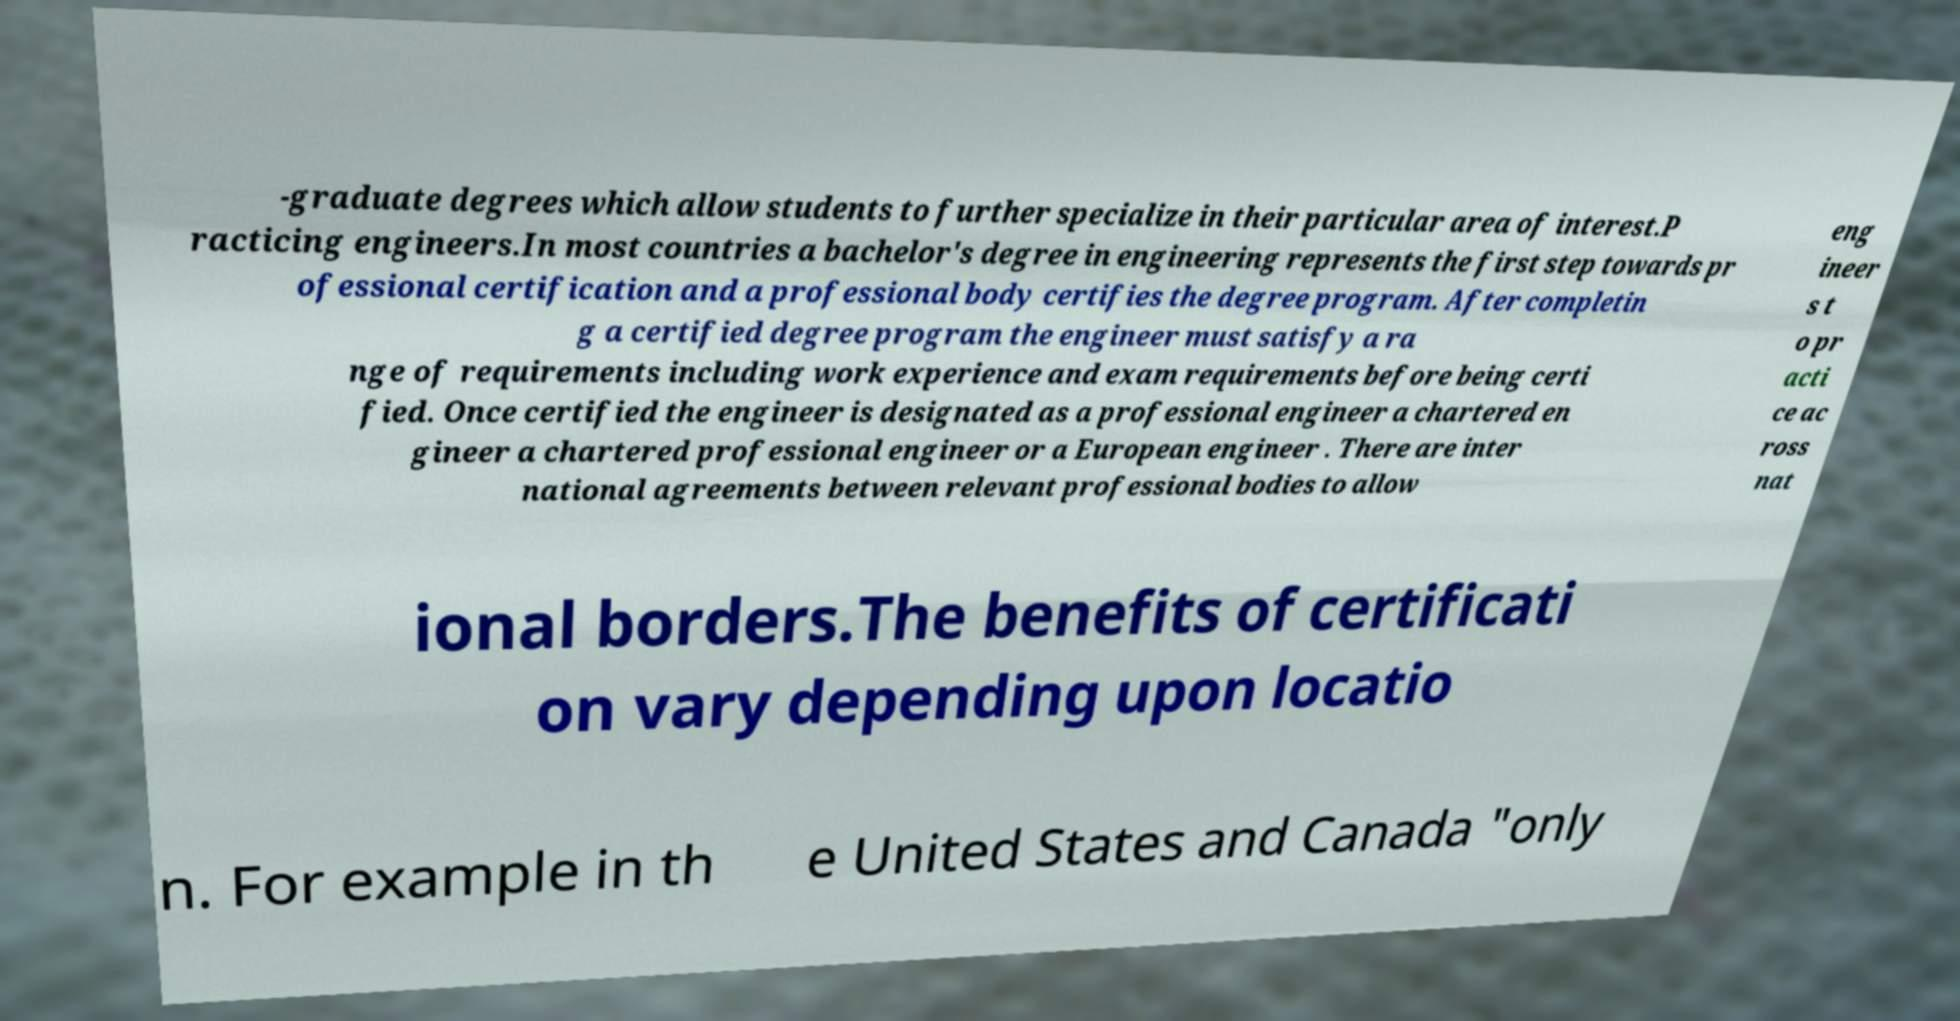Could you extract and type out the text from this image? -graduate degrees which allow students to further specialize in their particular area of interest.P racticing engineers.In most countries a bachelor's degree in engineering represents the first step towards pr ofessional certification and a professional body certifies the degree program. After completin g a certified degree program the engineer must satisfy a ra nge of requirements including work experience and exam requirements before being certi fied. Once certified the engineer is designated as a professional engineer a chartered en gineer a chartered professional engineer or a European engineer . There are inter national agreements between relevant professional bodies to allow eng ineer s t o pr acti ce ac ross nat ional borders.The benefits of certificati on vary depending upon locatio n. For example in th e United States and Canada "only 